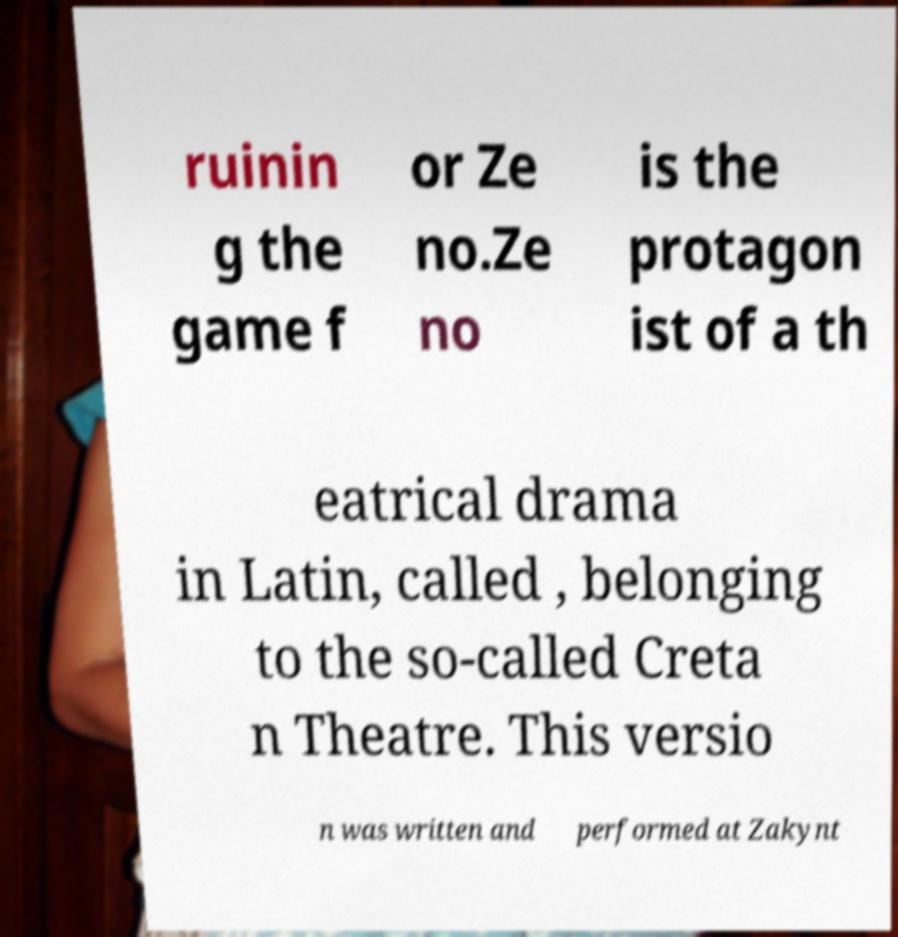Please identify and transcribe the text found in this image. ruinin g the game f or Ze no.Ze no is the protagon ist of a th eatrical drama in Latin, called , belonging to the so-called Creta n Theatre. This versio n was written and performed at Zakynt 